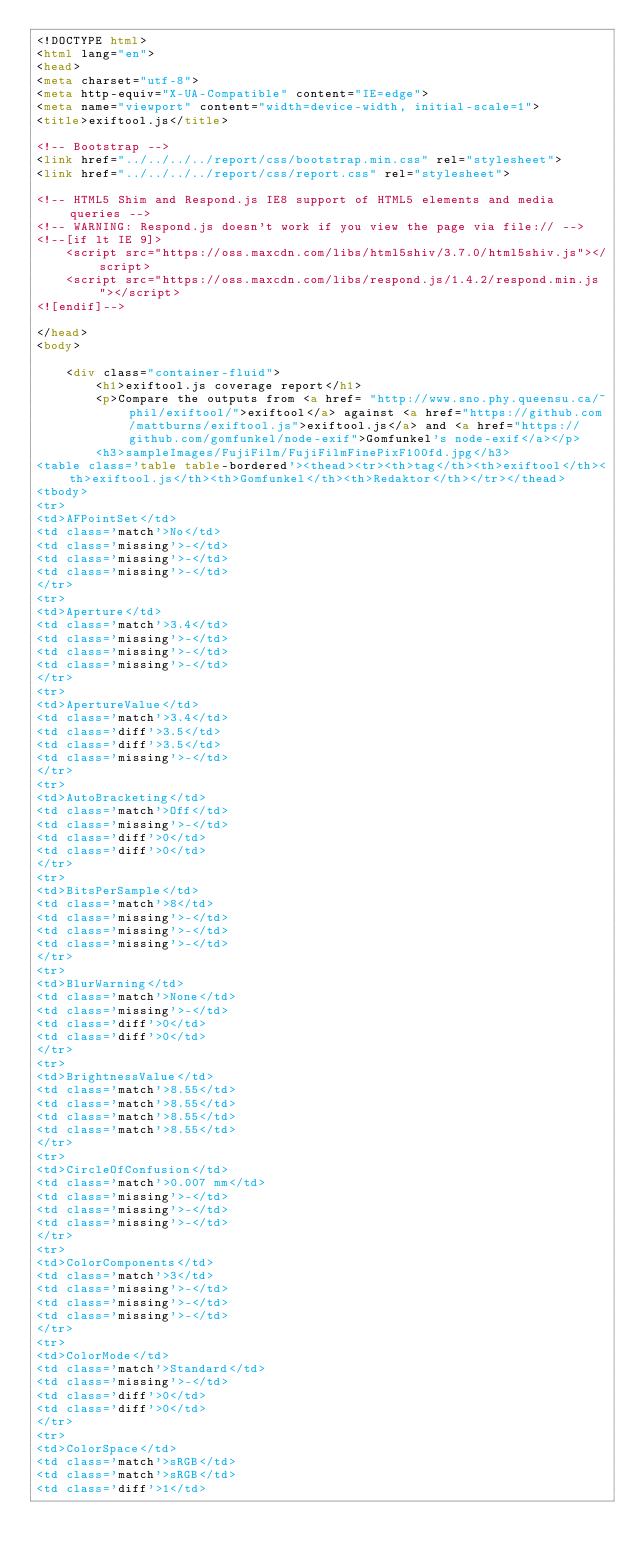<code> <loc_0><loc_0><loc_500><loc_500><_HTML_><!DOCTYPE html>
<html lang="en">
<head>
<meta charset="utf-8">
<meta http-equiv="X-UA-Compatible" content="IE=edge">
<meta name="viewport" content="width=device-width, initial-scale=1">
<title>exiftool.js</title>

<!-- Bootstrap -->
<link href="../../../../report/css/bootstrap.min.css" rel="stylesheet">
<link href="../../../../report/css/report.css" rel="stylesheet">

<!-- HTML5 Shim and Respond.js IE8 support of HTML5 elements and media queries -->
<!-- WARNING: Respond.js doesn't work if you view the page via file:// -->
<!--[if lt IE 9]>
    <script src="https://oss.maxcdn.com/libs/html5shiv/3.7.0/html5shiv.js"></script>
    <script src="https://oss.maxcdn.com/libs/respond.js/1.4.2/respond.min.js"></script>
<![endif]-->

</head>
<body>

    <div class="container-fluid">
        <h1>exiftool.js coverage report</h1>
        <p>Compare the outputs from <a href= "http://www.sno.phy.queensu.ca/~phil/exiftool/">exiftool</a> against <a href="https://github.com/mattburns/exiftool.js">exiftool.js</a> and <a href="https://github.com/gomfunkel/node-exif">Gomfunkel's node-exif</a></p>
        <h3>sampleImages/FujiFilm/FujiFilmFinePixF100fd.jpg</h3>
<table class='table table-bordered'><thead><tr><th>tag</th><th>exiftool</th><th>exiftool.js</th><th>Gomfunkel</th><th>Redaktor</th></tr></thead>
<tbody>
<tr>
<td>AFPointSet</td>
<td class='match'>No</td>
<td class='missing'>-</td>
<td class='missing'>-</td>
<td class='missing'>-</td>
</tr>
<tr>
<td>Aperture</td>
<td class='match'>3.4</td>
<td class='missing'>-</td>
<td class='missing'>-</td>
<td class='missing'>-</td>
</tr>
<tr>
<td>ApertureValue</td>
<td class='match'>3.4</td>
<td class='diff'>3.5</td>
<td class='diff'>3.5</td>
<td class='missing'>-</td>
</tr>
<tr>
<td>AutoBracketing</td>
<td class='match'>Off</td>
<td class='missing'>-</td>
<td class='diff'>0</td>
<td class='diff'>0</td>
</tr>
<tr>
<td>BitsPerSample</td>
<td class='match'>8</td>
<td class='missing'>-</td>
<td class='missing'>-</td>
<td class='missing'>-</td>
</tr>
<tr>
<td>BlurWarning</td>
<td class='match'>None</td>
<td class='missing'>-</td>
<td class='diff'>0</td>
<td class='diff'>0</td>
</tr>
<tr>
<td>BrightnessValue</td>
<td class='match'>8.55</td>
<td class='match'>8.55</td>
<td class='match'>8.55</td>
<td class='match'>8.55</td>
</tr>
<tr>
<td>CircleOfConfusion</td>
<td class='match'>0.007 mm</td>
<td class='missing'>-</td>
<td class='missing'>-</td>
<td class='missing'>-</td>
</tr>
<tr>
<td>ColorComponents</td>
<td class='match'>3</td>
<td class='missing'>-</td>
<td class='missing'>-</td>
<td class='missing'>-</td>
</tr>
<tr>
<td>ColorMode</td>
<td class='match'>Standard</td>
<td class='missing'>-</td>
<td class='diff'>0</td>
<td class='diff'>0</td>
</tr>
<tr>
<td>ColorSpace</td>
<td class='match'>sRGB</td>
<td class='match'>sRGB</td>
<td class='diff'>1</td></code> 